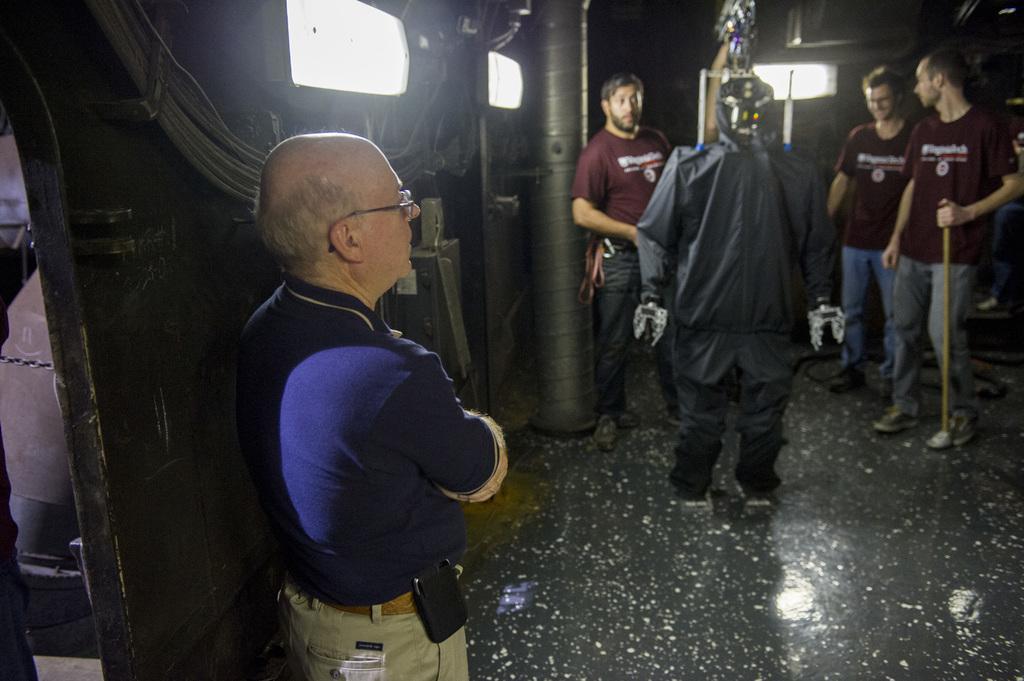In one or two sentences, can you explain what this image depicts? In this image we can see a robot with black costume. We can also see four persons standing on the floor and there is a person holding the stick on the right. Image also consists of lights, ropes and also a pillar. 